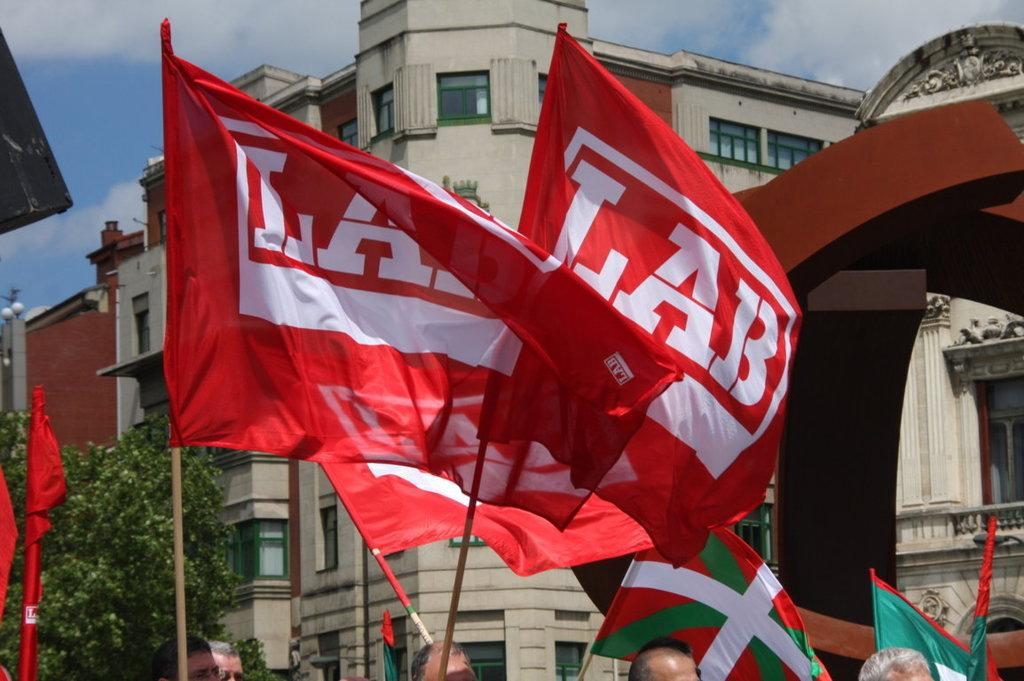What colors are present on the flags in the image? The flags in the image have red, white, and green colors. What can be seen in the background of the image? There are buildings and trees with green leaves in the background of the image. What is the color of the sky in the image? The sky is blue and white in color. How much dust can be seen on the trees in the image? There is no mention of dust in the image, and therefore it cannot be determined how much dust is present on the trees. 